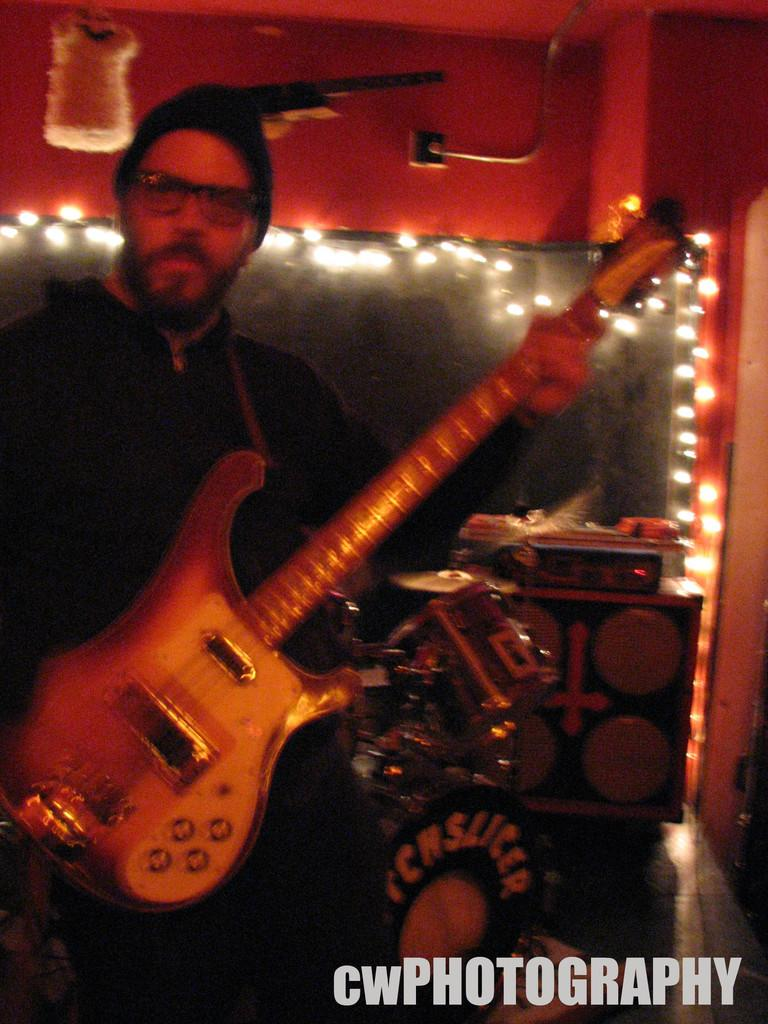Who is in the image? There is a person in the image. What is the person wearing? The person is wearing a black dress and a black cap. What is the person doing in the image? The person is playing a guitar. What can be seen in the background of the image? There is a box in the background of the image. What type of soup is being served in the cave in the image? There is no cave or soup present in the image; it features a person playing a guitar. Is there a watch visible on the person's wrist in the image? There is no watch visible on the person's wrist in the image. 